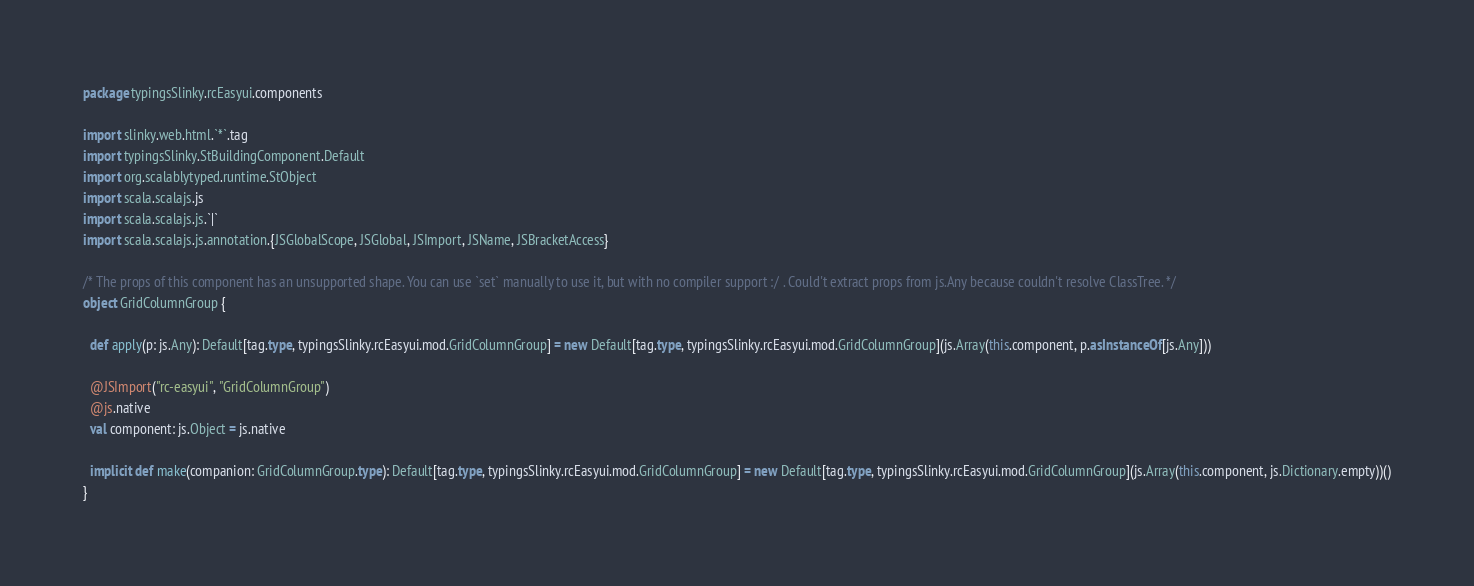<code> <loc_0><loc_0><loc_500><loc_500><_Scala_>package typingsSlinky.rcEasyui.components

import slinky.web.html.`*`.tag
import typingsSlinky.StBuildingComponent.Default
import org.scalablytyped.runtime.StObject
import scala.scalajs.js
import scala.scalajs.js.`|`
import scala.scalajs.js.annotation.{JSGlobalScope, JSGlobal, JSImport, JSName, JSBracketAccess}

/* The props of this component has an unsupported shape. You can use `set` manually to use it, but with no compiler support :/ . Could't extract props from js.Any because couldn't resolve ClassTree. */
object GridColumnGroup {
  
  def apply(p: js.Any): Default[tag.type, typingsSlinky.rcEasyui.mod.GridColumnGroup] = new Default[tag.type, typingsSlinky.rcEasyui.mod.GridColumnGroup](js.Array(this.component, p.asInstanceOf[js.Any]))
  
  @JSImport("rc-easyui", "GridColumnGroup")
  @js.native
  val component: js.Object = js.native
  
  implicit def make(companion: GridColumnGroup.type): Default[tag.type, typingsSlinky.rcEasyui.mod.GridColumnGroup] = new Default[tag.type, typingsSlinky.rcEasyui.mod.GridColumnGroup](js.Array(this.component, js.Dictionary.empty))()
}
</code> 